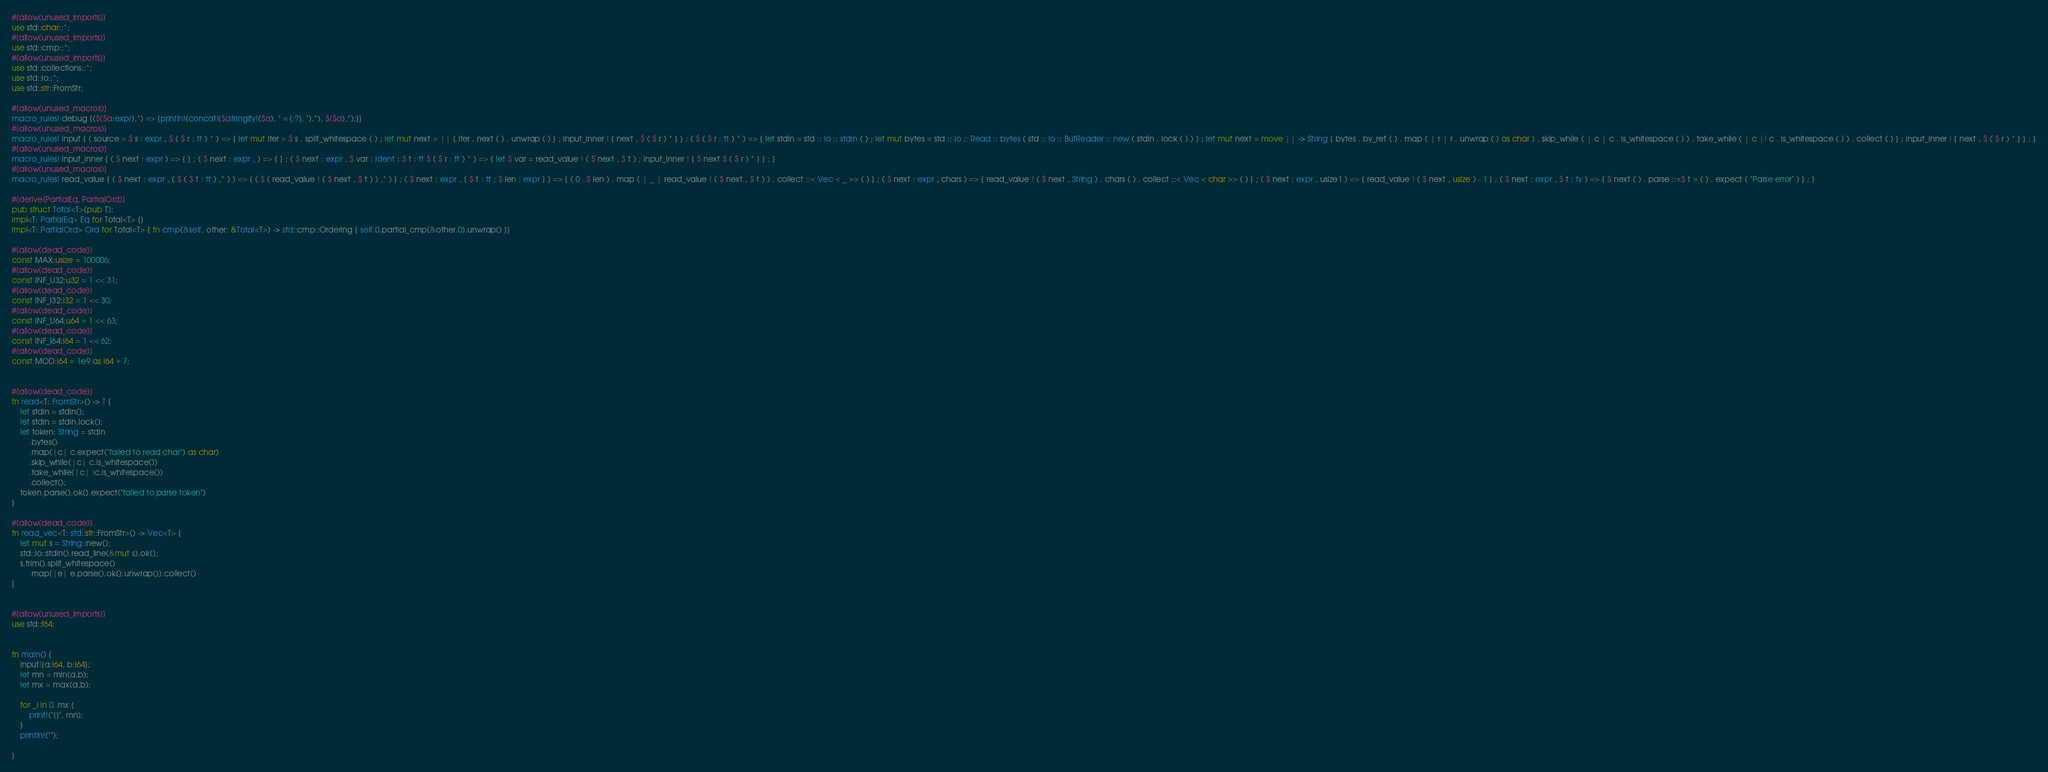<code> <loc_0><loc_0><loc_500><loc_500><_Rust_>#[allow(unused_imports)]
use std::char::*;
#[allow(unused_imports)]
use std::cmp::*;
#[allow(unused_imports)]
use std::collections::*;
use std::io::*;
use std::str::FromStr;

#[allow(unused_macros)]
macro_rules! debug {($($a:expr),*) => {println!(concat!($(stringify!($a), " = {:?}, "),*), $($a),*);}}
#[allow(unused_macros)]
macro_rules! input { ( source = $ s : expr , $ ( $ r : tt ) * ) => { let mut iter = $ s . split_whitespace ( ) ; let mut next = || { iter . next ( ) . unwrap ( ) } ; input_inner ! { next , $ ( $ r ) * } } ; ( $ ( $ r : tt ) * ) => { let stdin = std :: io :: stdin ( ) ; let mut bytes = std :: io :: Read :: bytes ( std :: io :: BufReader :: new ( stdin . lock ( ) ) ) ; let mut next = move || -> String { bytes . by_ref ( ) . map ( | r | r . unwrap ( ) as char ) . skip_while ( | c | c . is_whitespace ( ) ) . take_while ( | c |! c . is_whitespace ( ) ) . collect ( ) } ; input_inner ! { next , $ ( $ r ) * } } ; }
#[allow(unused_macros)]
macro_rules! input_inner { ( $ next : expr ) => { } ; ( $ next : expr , ) => { } ; ( $ next : expr , $ var : ident : $ t : tt $ ( $ r : tt ) * ) => { let $ var = read_value ! ( $ next , $ t ) ; input_inner ! { $ next $ ( $ r ) * } } ; }
#[allow(unused_macros)]
macro_rules! read_value { ( $ next : expr , ( $ ( $ t : tt ) ,* ) ) => { ( $ ( read_value ! ( $ next , $ t ) ) ,* ) } ; ( $ next : expr , [ $ t : tt ; $ len : expr ] ) => { ( 0 ..$ len ) . map ( | _ | read_value ! ( $ next , $ t ) ) . collect ::< Vec < _ >> ( ) } ; ( $ next : expr , chars ) => { read_value ! ( $ next , String ) . chars ( ) . collect ::< Vec < char >> ( ) } ; ( $ next : expr , usize1 ) => { read_value ! ( $ next , usize ) - 1 } ; ( $ next : expr , $ t : ty ) => { $ next ( ) . parse ::<$ t > ( ) . expect ( "Parse error" ) } ; }

#[derive(PartialEq, PartialOrd)]
pub struct Total<T>(pub T);
impl<T: PartialEq> Eq for Total<T> {}
impl<T: PartialOrd> Ord for Total<T> { fn cmp(&self, other: &Total<T>) -> std::cmp::Ordering { self.0.partial_cmp(&other.0).unwrap() }}

#[allow(dead_code)]
const MAX:usize = 100006;
#[allow(dead_code)]
const INF_U32:u32 = 1 << 31;
#[allow(dead_code)]
const INF_I32:i32 = 1 << 30;
#[allow(dead_code)]
const INF_U64:u64 = 1 << 63;
#[allow(dead_code)]
const INF_I64:i64 = 1 << 62;
#[allow(dead_code)]
const MOD:i64 = 1e9 as i64 + 7;


#[allow(dead_code)]
fn read<T: FromStr>() -> T {
    let stdin = stdin();
    let stdin = stdin.lock();
    let token: String = stdin
        .bytes()
        .map(|c| c.expect("failed to read char") as char)
        .skip_while(|c| c.is_whitespace())
        .take_while(|c| !c.is_whitespace())
        .collect();
    token.parse().ok().expect("failed to parse token")
}

#[allow(dead_code)]
fn read_vec<T: std::str::FromStr>() -> Vec<T> {
    let mut s = String::new();
    std::io::stdin().read_line(&mut s).ok();
    s.trim().split_whitespace()
        .map(|e| e.parse().ok().unwrap()).collect()
}


#[allow(unused_imports)]
use std::f64;


fn main() {
    input!{a:i64, b:i64};
    let mn = min(a,b);
    let mx = max(a,b);

    for _i in 0..mx {
        print!("{}", mn);
    }
    println!("");

}</code> 